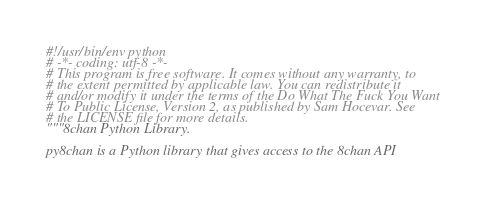Convert code to text. <code><loc_0><loc_0><loc_500><loc_500><_Python_>#!/usr/bin/env python
# -*- coding: utf-8 -*-
# This program is free software. It comes without any warranty, to
# the extent permitted by applicable law. You can redistribute it
# and/or modify it under the terms of the Do What The Fuck You Want
# To Public License, Version 2, as published by Sam Hocevar. See
# the LICENSE file for more details.
"""8chan Python Library.

py8chan is a Python library that gives access to the 8chan API</code> 